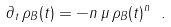Convert formula to latex. <formula><loc_0><loc_0><loc_500><loc_500>\partial _ { t } \, \rho _ { B } ( t ) = - n \, \mu \, \rho _ { B } ( t ) ^ { n } \ .</formula> 